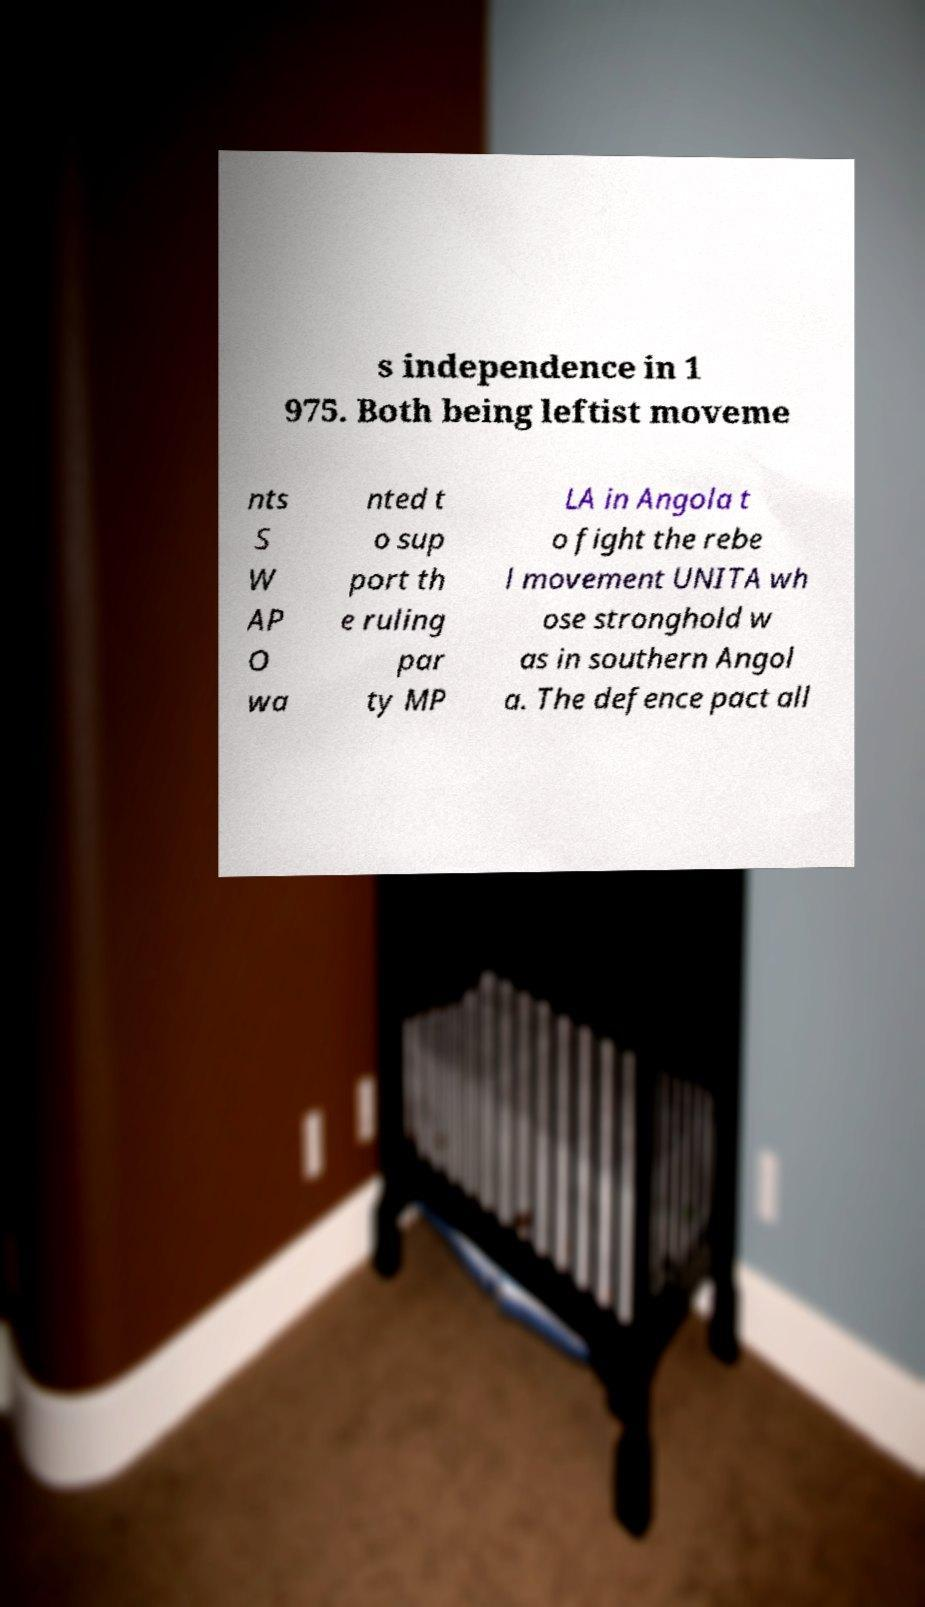Can you accurately transcribe the text from the provided image for me? s independence in 1 975. Both being leftist moveme nts S W AP O wa nted t o sup port th e ruling par ty MP LA in Angola t o fight the rebe l movement UNITA wh ose stronghold w as in southern Angol a. The defence pact all 